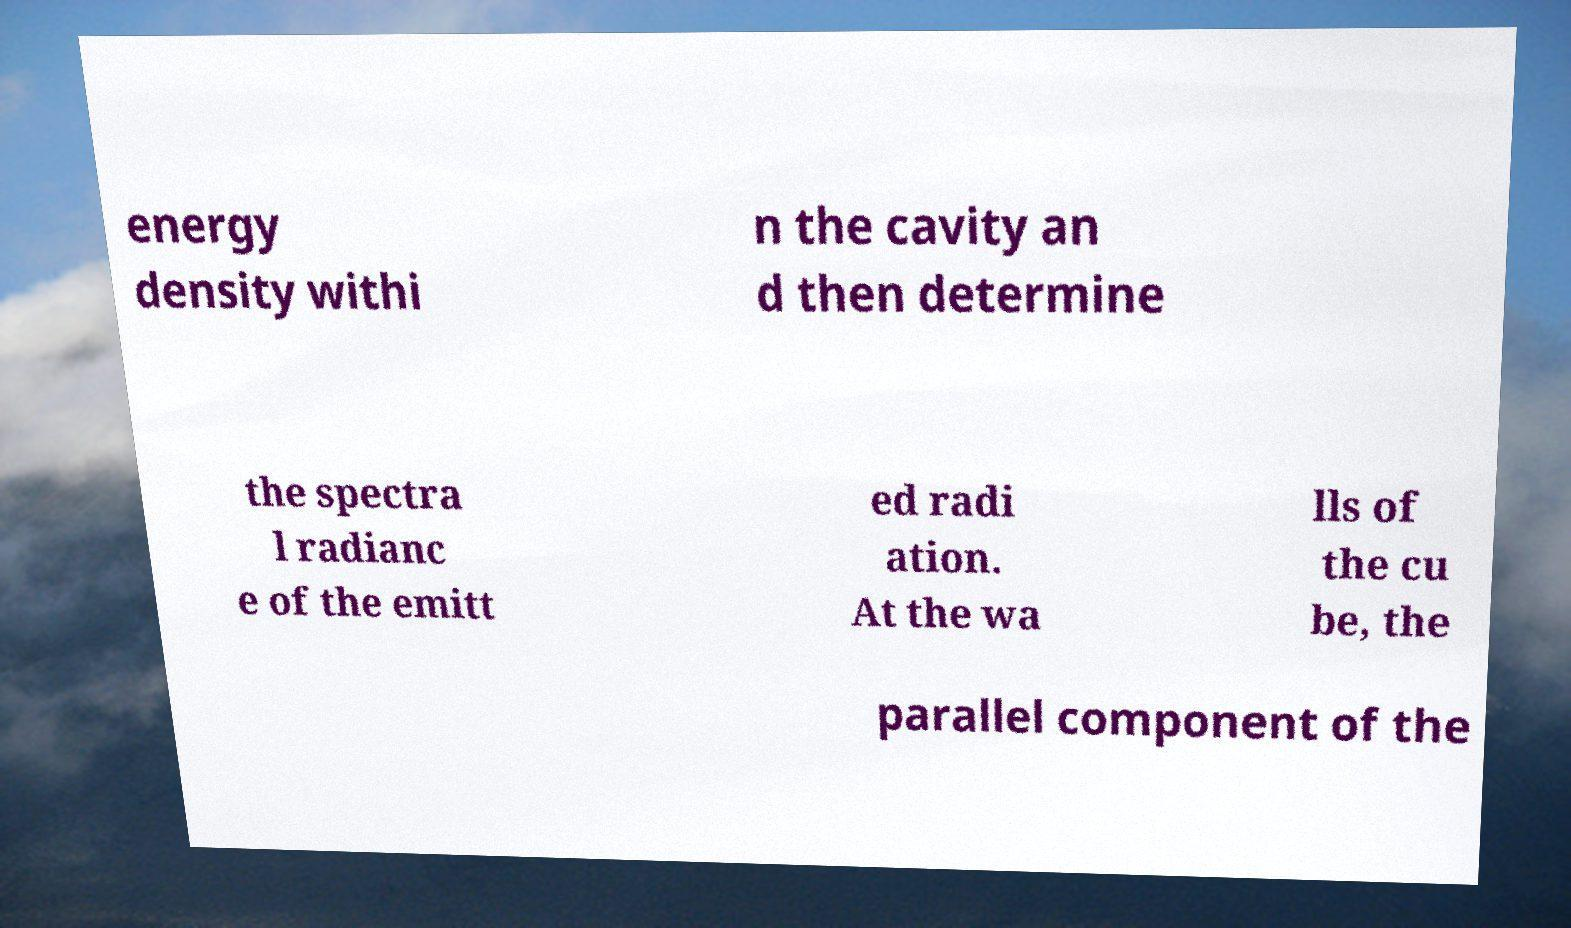Could you extract and type out the text from this image? energy density withi n the cavity an d then determine the spectra l radianc e of the emitt ed radi ation. At the wa lls of the cu be, the parallel component of the 